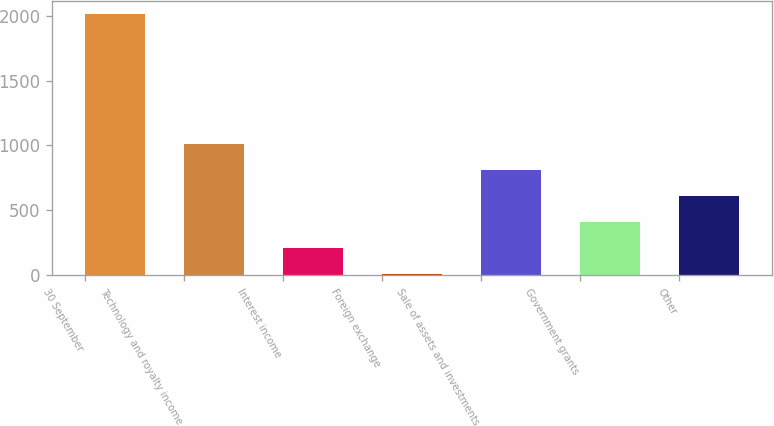Convert chart. <chart><loc_0><loc_0><loc_500><loc_500><bar_chart><fcel>30 September<fcel>Technology and royalty income<fcel>Interest income<fcel>Foreign exchange<fcel>Sale of assets and investments<fcel>Government grants<fcel>Other<nl><fcel>2013<fcel>1008.1<fcel>204.18<fcel>3.2<fcel>807.12<fcel>405.16<fcel>606.14<nl></chart> 